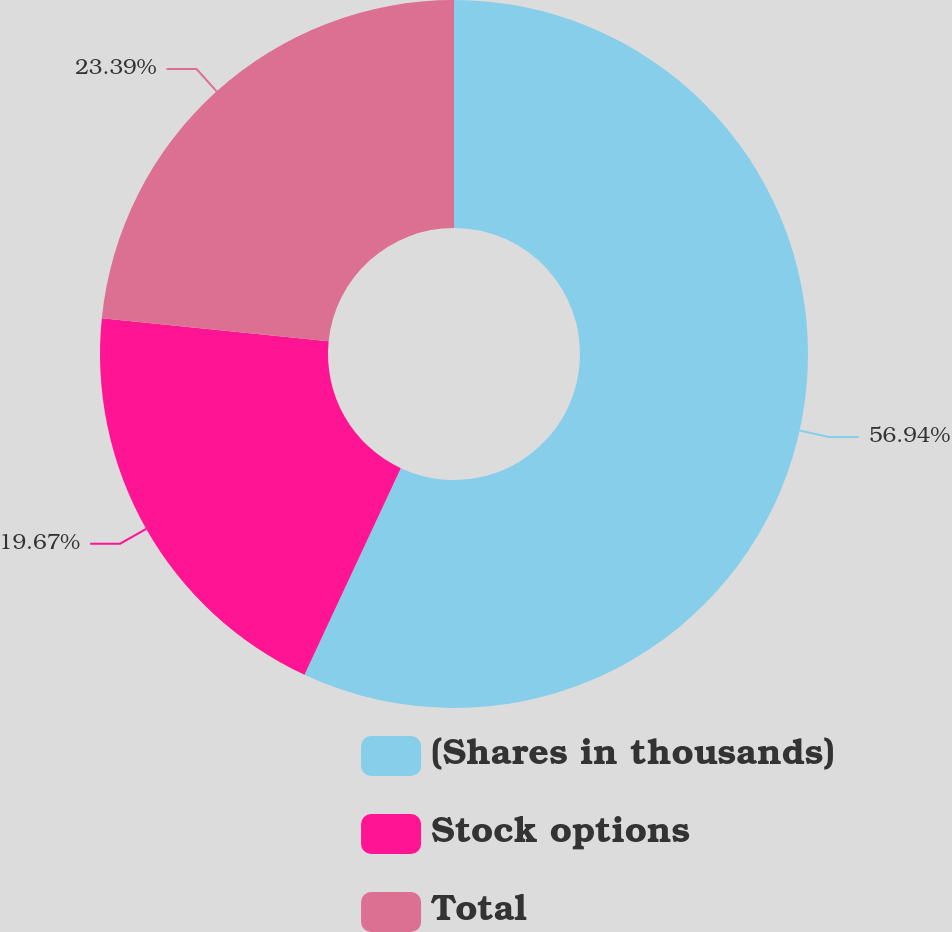Convert chart. <chart><loc_0><loc_0><loc_500><loc_500><pie_chart><fcel>(Shares in thousands)<fcel>Stock options<fcel>Total<nl><fcel>56.94%<fcel>19.67%<fcel>23.39%<nl></chart> 